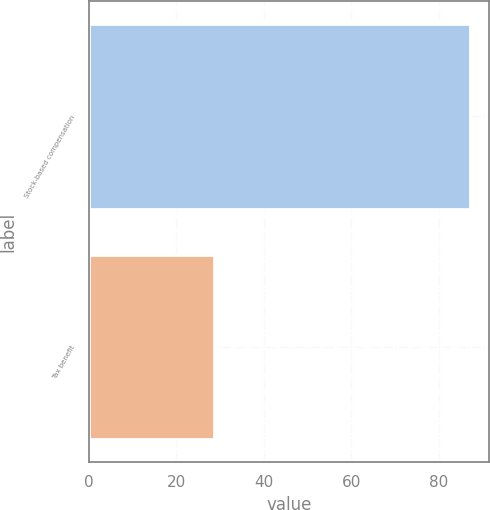Convert chart. <chart><loc_0><loc_0><loc_500><loc_500><bar_chart><fcel>Stock-based compensation<fcel>Tax benefit<nl><fcel>87.2<fcel>28.6<nl></chart> 